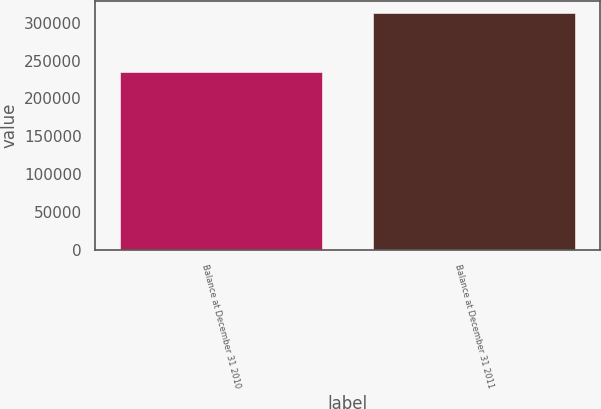Convert chart to OTSL. <chart><loc_0><loc_0><loc_500><loc_500><bar_chart><fcel>Balance at December 31 2010<fcel>Balance at December 31 2011<nl><fcel>234476<fcel>312439<nl></chart> 